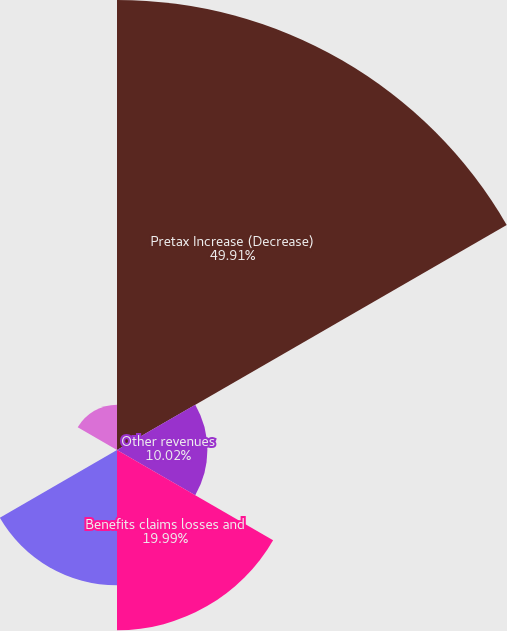<chart> <loc_0><loc_0><loc_500><loc_500><pie_chart><fcel>Pretax Increase (Decrease)<fcel>Other revenues<fcel>Benefits claims losses and<fcel>Amortization of DAC<fcel>Total expenses<fcel>Total (1)<nl><fcel>49.9%<fcel>10.02%<fcel>19.99%<fcel>15.0%<fcel>0.05%<fcel>5.03%<nl></chart> 